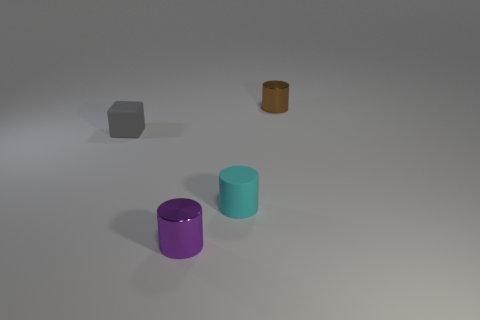Is the material of the cyan object the same as the object that is to the left of the tiny purple cylinder? Yes, the material appears to be the same for both objects. They exhibit similar matte finishes and the way light reflects off of their surfaces suggests they could be made from a similar plastic or painted material. 